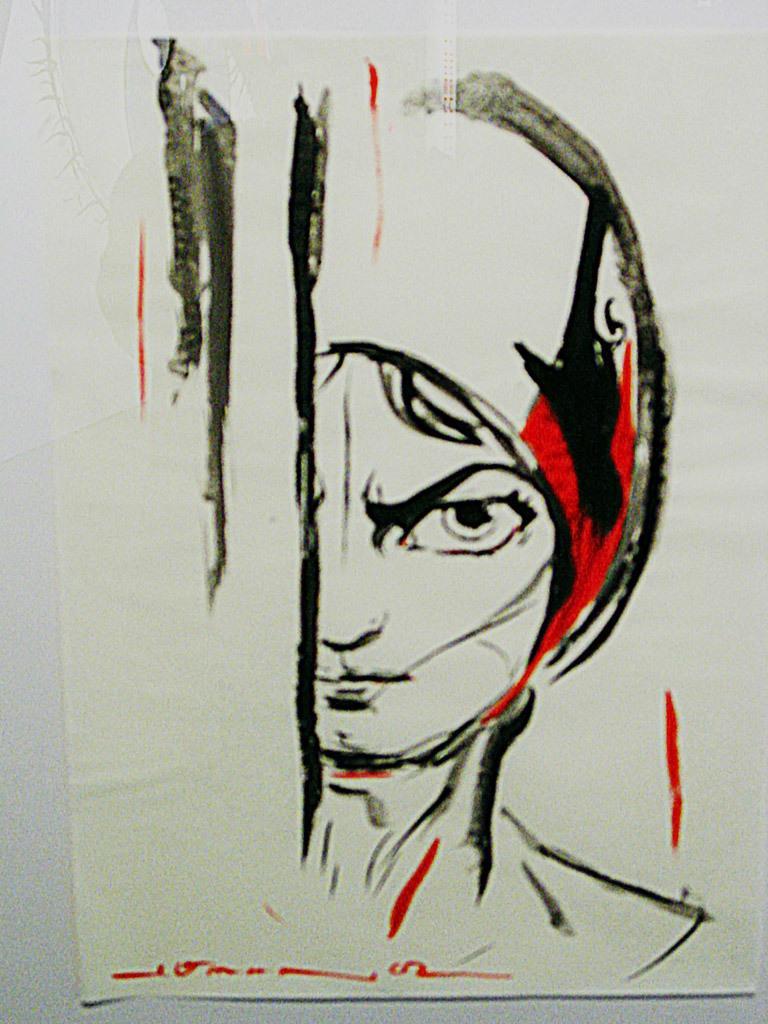Could you give a brief overview of what you see in this image? This image consists of a paper with an art of a human on it. 